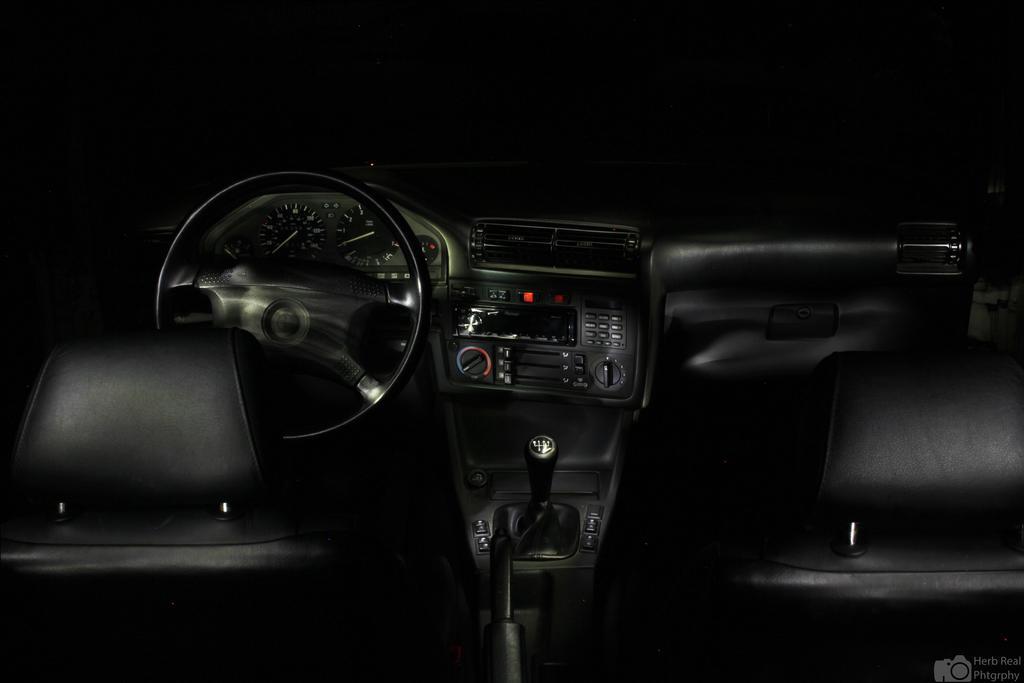Please provide a concise description of this image. As we can see in the image there is a vehicle and steering. 